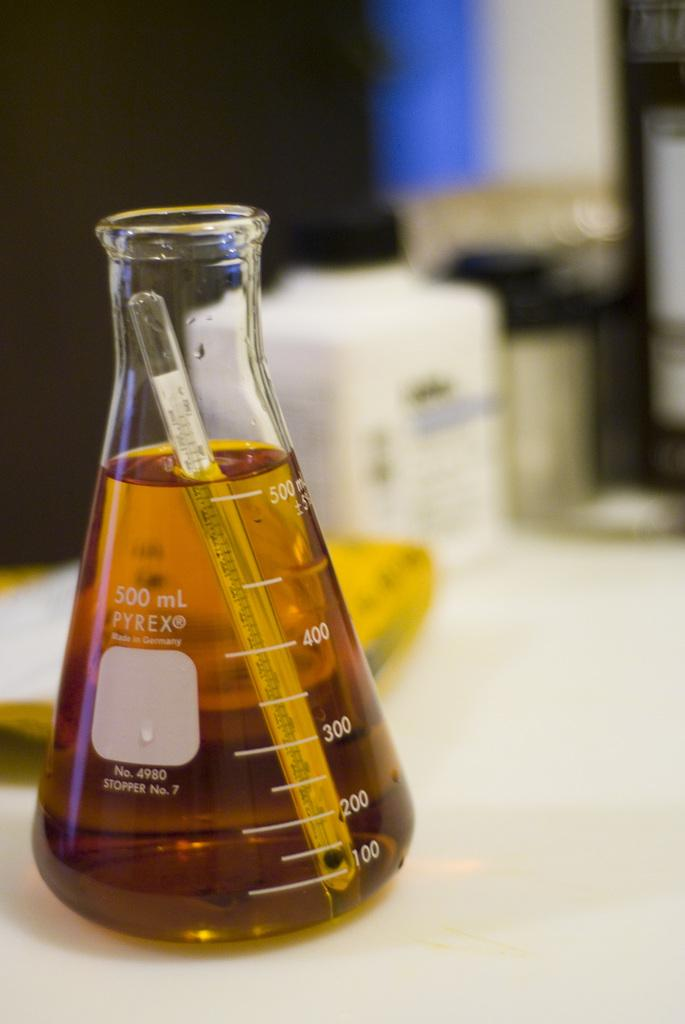<image>
Write a terse but informative summary of the picture. A measuring glass that can hold 500 millileters 